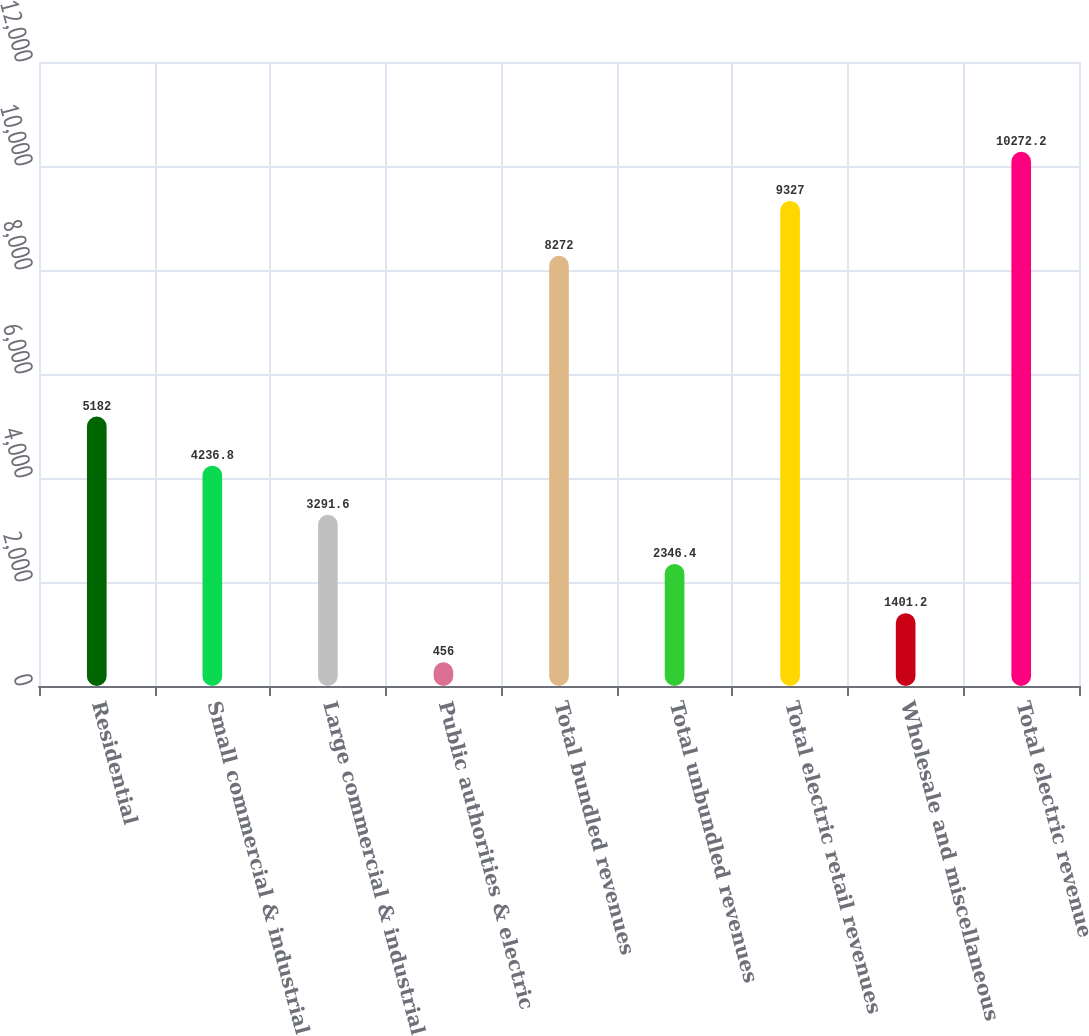Convert chart to OTSL. <chart><loc_0><loc_0><loc_500><loc_500><bar_chart><fcel>Residential<fcel>Small commercial & industrial<fcel>Large commercial & industrial<fcel>Public authorities & electric<fcel>Total bundled revenues<fcel>Total unbundled revenues<fcel>Total electric retail revenues<fcel>Wholesale and miscellaneous<fcel>Total electric revenue<nl><fcel>5182<fcel>4236.8<fcel>3291.6<fcel>456<fcel>8272<fcel>2346.4<fcel>9327<fcel>1401.2<fcel>10272.2<nl></chart> 